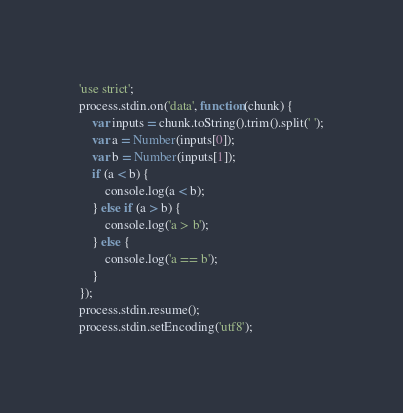<code> <loc_0><loc_0><loc_500><loc_500><_JavaScript_>'use strict';
process.stdin.on('data', function(chunk) {
    var inputs = chunk.toString().trim().split(' ');
    var a = Number(inputs[0]);
    var b = Number(inputs[1]);
    if (a < b) {
        console.log(a < b);
    } else if (a > b) {
        console.log('a > b');
    } else {
        console.log('a == b');
    }
});
process.stdin.resume();
process.stdin.setEncoding('utf8');</code> 